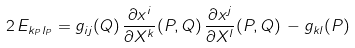Convert formula to latex. <formula><loc_0><loc_0><loc_500><loc_500>2 \, E _ { k _ { P } l _ { P } } = g _ { i j } ( Q ) \, \frac { \partial x ^ { i } } { \partial X ^ { k } } ( P , Q ) \, \frac { \partial x ^ { j } } { \partial X ^ { l } } ( P , Q ) \, - g _ { k l } ( P )</formula> 